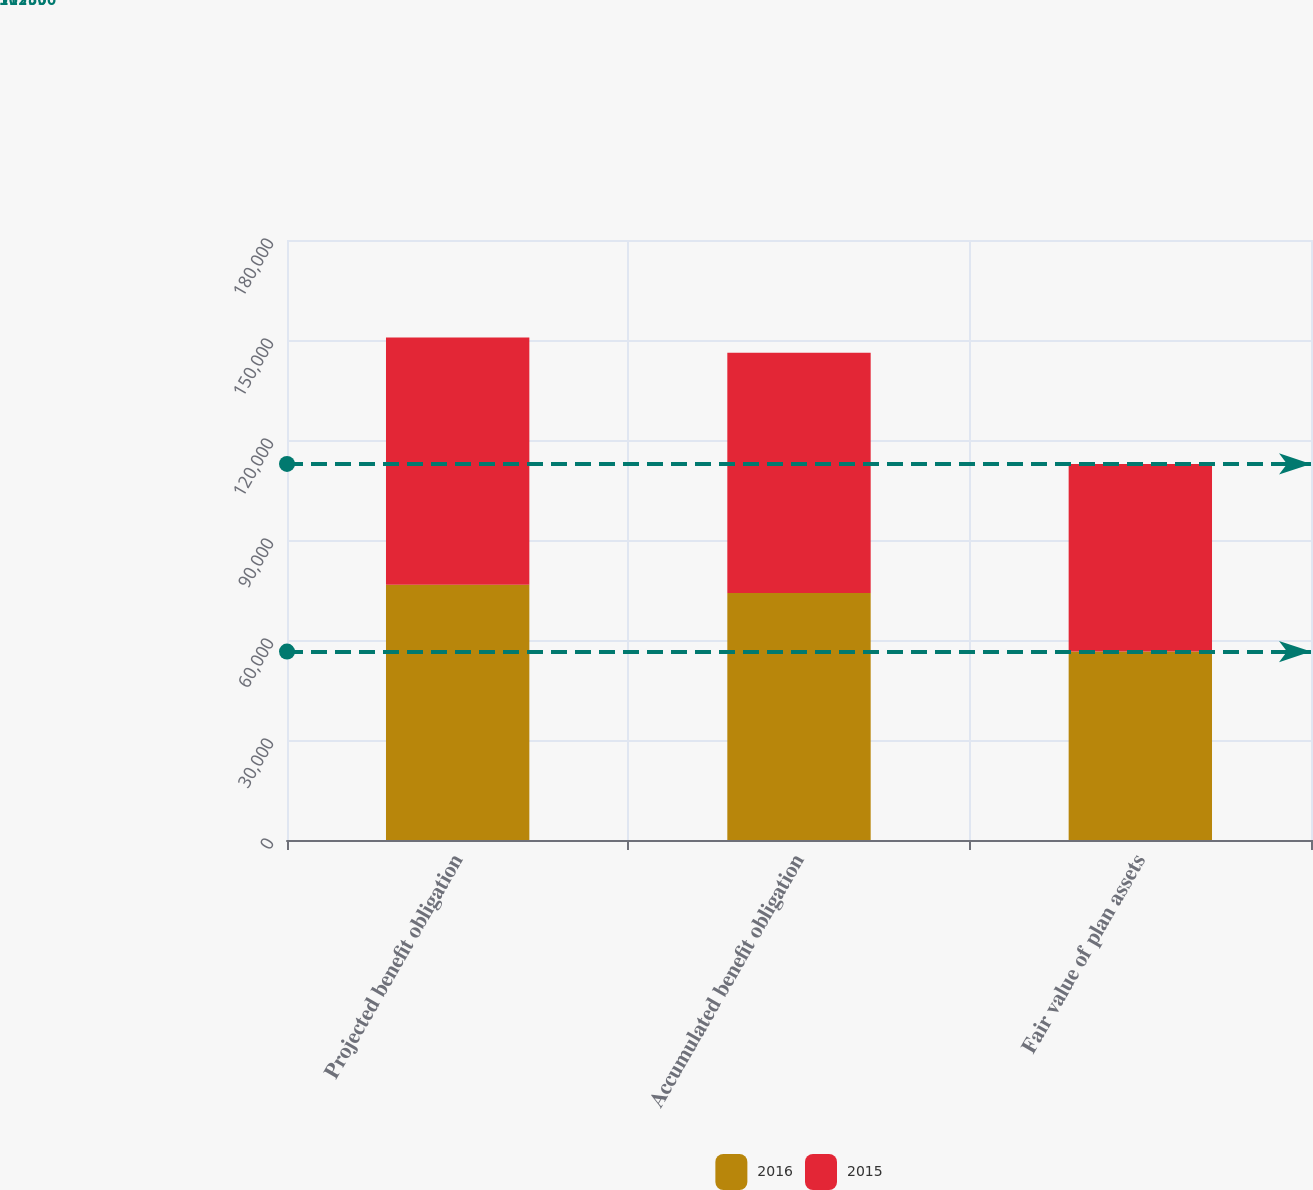<chart> <loc_0><loc_0><loc_500><loc_500><stacked_bar_chart><ecel><fcel>Projected benefit obligation<fcel>Accumulated benefit obligation<fcel>Fair value of plan assets<nl><fcel>2016<fcel>76586<fcel>74081<fcel>56530<nl><fcel>2015<fcel>74188<fcel>72121<fcel>56306<nl></chart> 